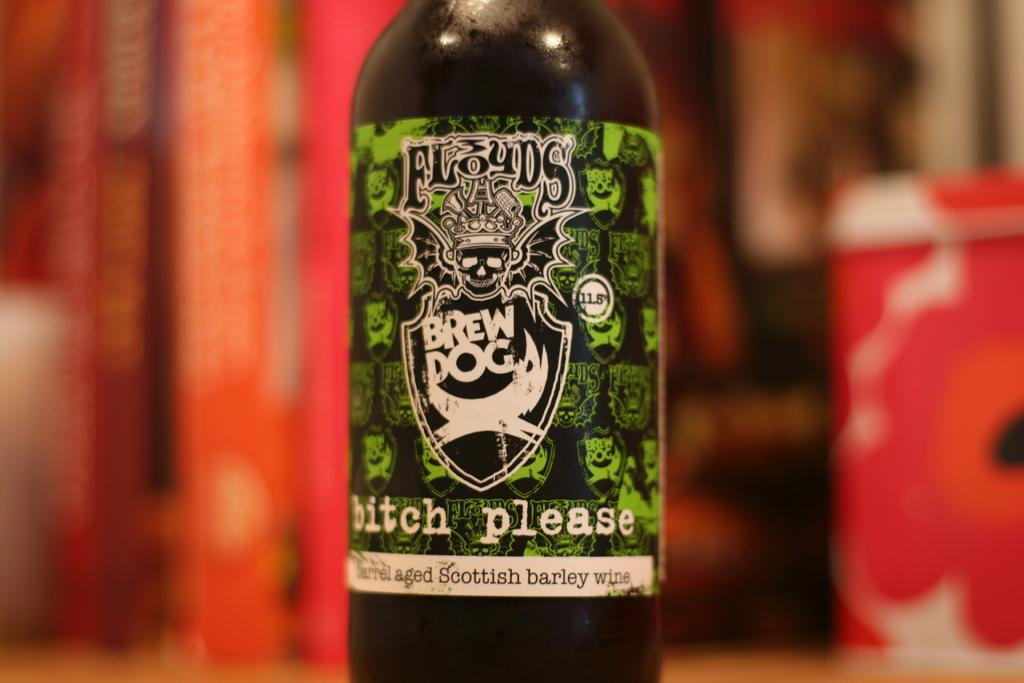What is the main object in the image? There is a wine bottle in the image. Can you describe the background of the image? The background of the image is blurred. What type of liquid can be seen rolling down the plough in the image? There is no plough or liquid present in the image; it features a wine bottle and a blurred background. 